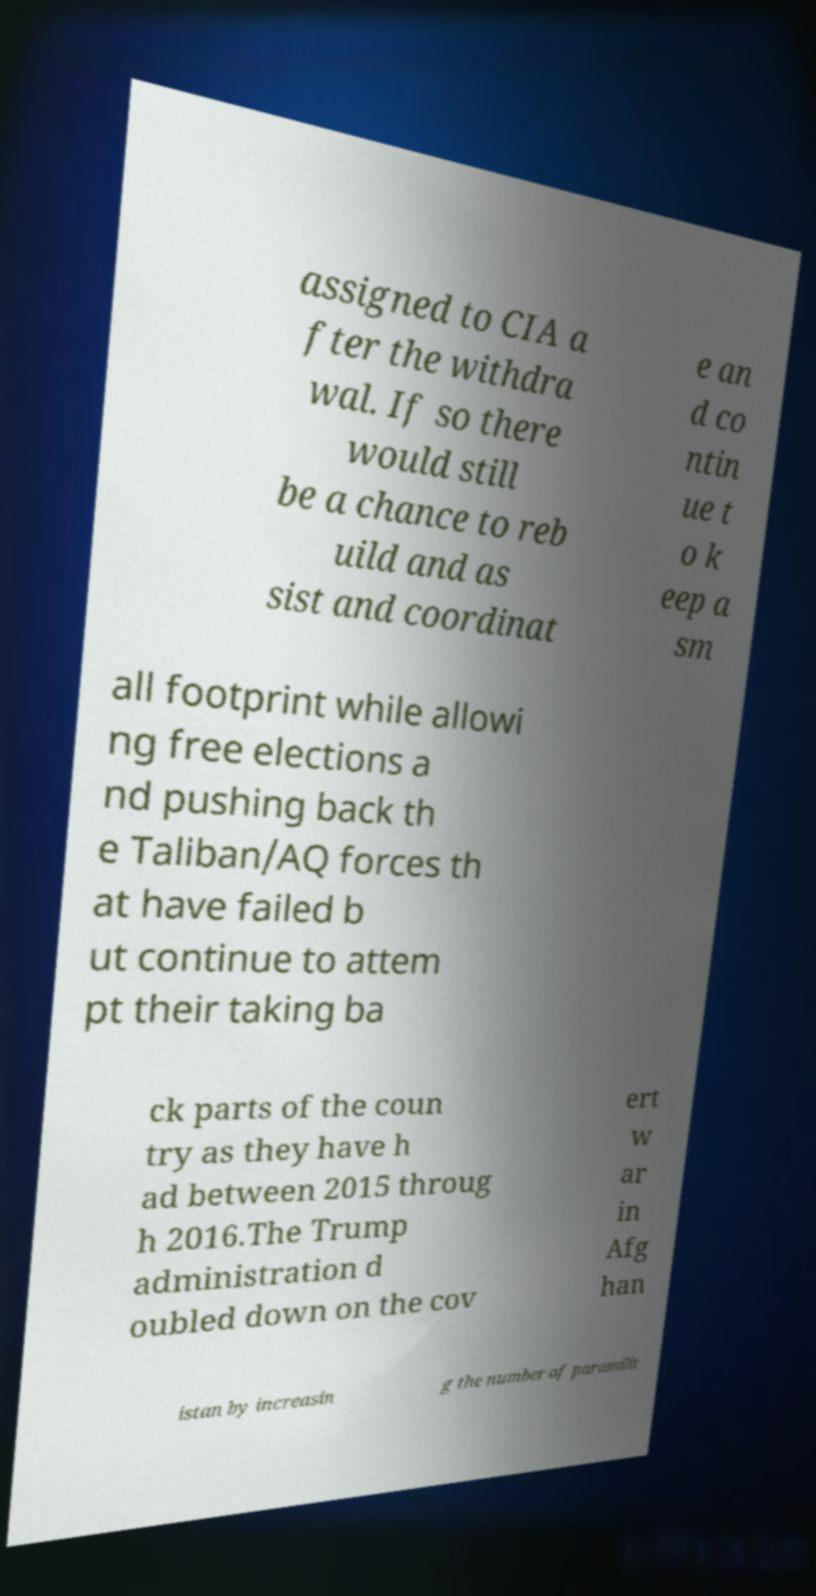What messages or text are displayed in this image? I need them in a readable, typed format. assigned to CIA a fter the withdra wal. If so there would still be a chance to reb uild and as sist and coordinat e an d co ntin ue t o k eep a sm all footprint while allowi ng free elections a nd pushing back th e Taliban/AQ forces th at have failed b ut continue to attem pt their taking ba ck parts of the coun try as they have h ad between 2015 throug h 2016.The Trump administration d oubled down on the cov ert w ar in Afg han istan by increasin g the number of paramilit 